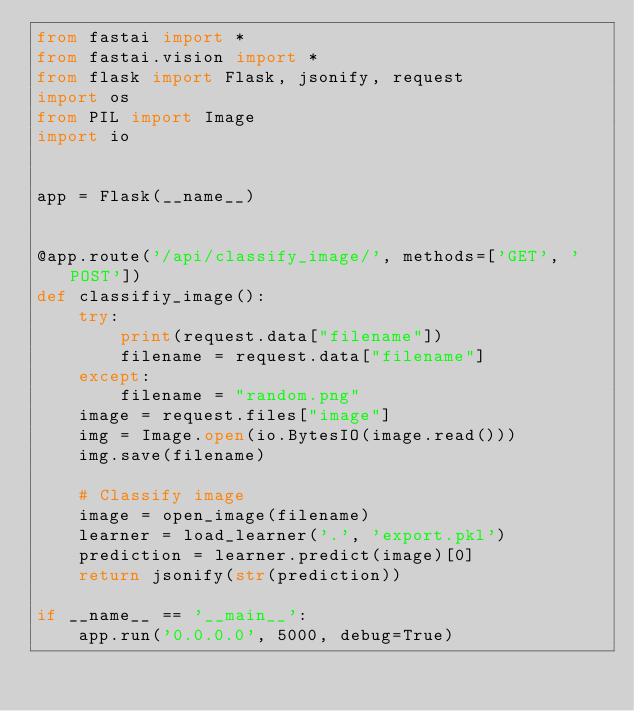Convert code to text. <code><loc_0><loc_0><loc_500><loc_500><_Python_>from fastai import *
from fastai.vision import *
from flask import Flask, jsonify, request
import os
from PIL import Image
import io


app = Flask(__name__)


@app.route('/api/classify_image/', methods=['GET', 'POST'])
def classifiy_image():
    try:
        print(request.data["filename"])
        filename = request.data["filename"]
    except:
        filename = "random.png"
    image = request.files["image"]
    img = Image.open(io.BytesIO(image.read()))
    img.save(filename)

    # Classify image
    image = open_image(filename)
    learner = load_learner('.', 'export.pkl')
    prediction = learner.predict(image)[0]
    return jsonify(str(prediction))

if __name__ == '__main__':
    app.run('0.0.0.0', 5000, debug=True)</code> 